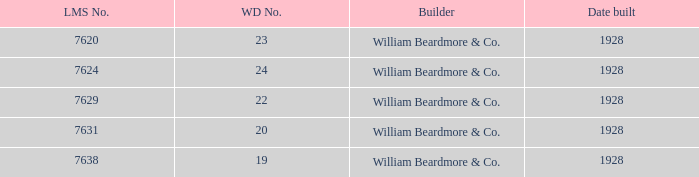Could you parse the entire table? {'header': ['LMS No.', 'WD No.', 'Builder', 'Date built'], 'rows': [['7620', '23', 'William Beardmore & Co.', '1928'], ['7624', '24', 'William Beardmore & Co.', '1928'], ['7629', '22', 'William Beardmore & Co.', '1928'], ['7631', '20', 'William Beardmore & Co.', '1928'], ['7638', '19', 'William Beardmore & Co.', '1928']]} How many serial numbers are there in total for 24 wd products? 1.0. 